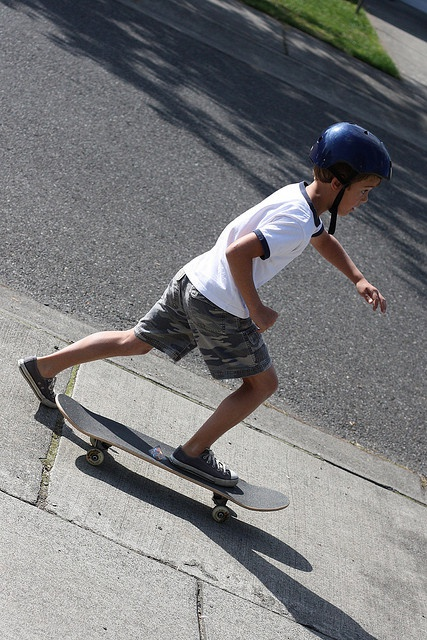Describe the objects in this image and their specific colors. I can see people in darkblue, black, maroon, white, and gray tones and skateboard in darkblue, black, darkgray, and gray tones in this image. 